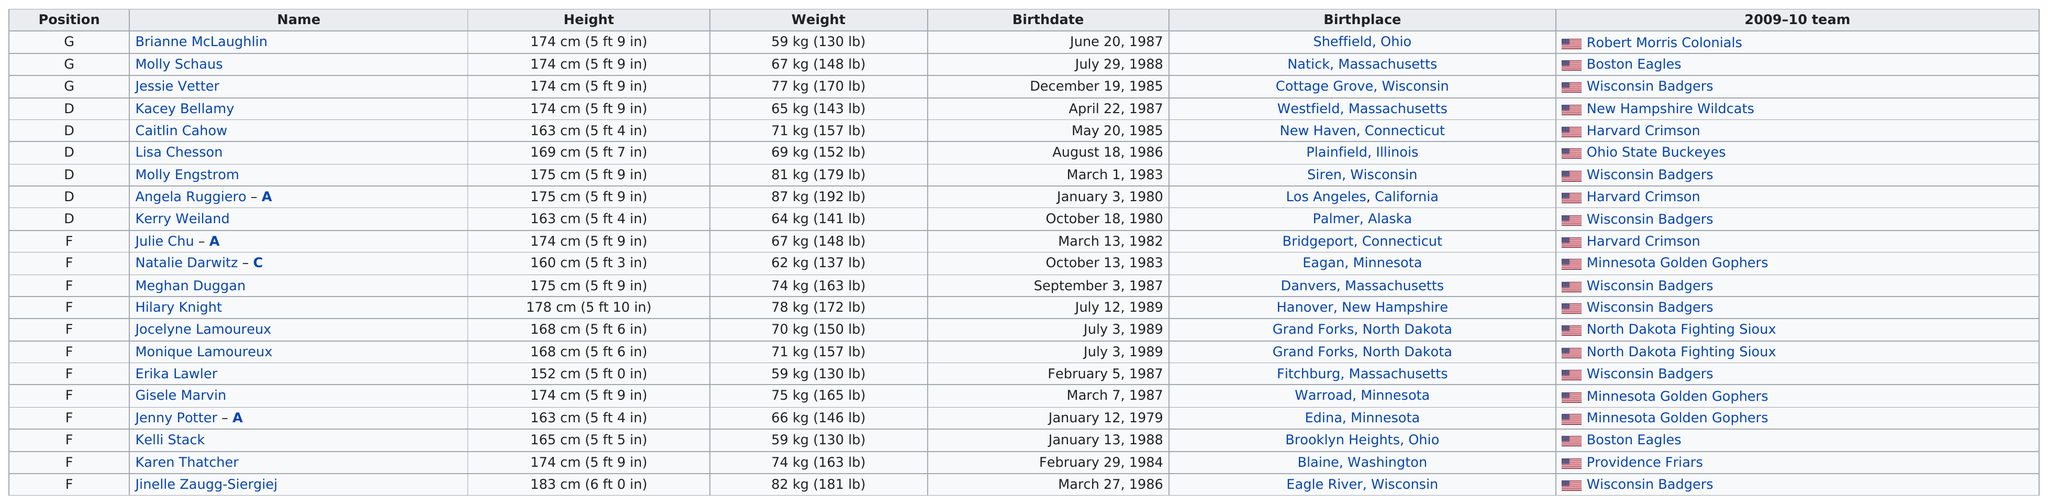Outline some significant characteristics in this image. The state that produced the most players on the 2010 U.S. Women's Olympic Hockey Roster was Massachusetts. There are two individuals whose height is at least 174 centimeters, named Brianne McLaughlin and Molly Schaus. Kelli Stack is a player who is taller than Erika Lawler. A total of 21 names are listed. What position has the most lists? It is Football. 